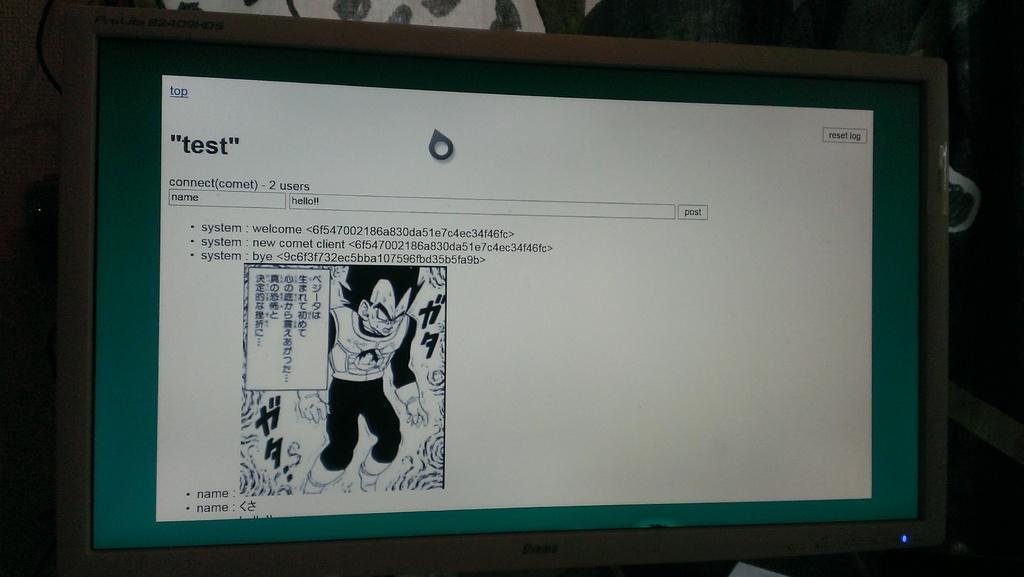<image>
Present a compact description of the photo's key features. A "test" website on a computer shows a cartoon. 